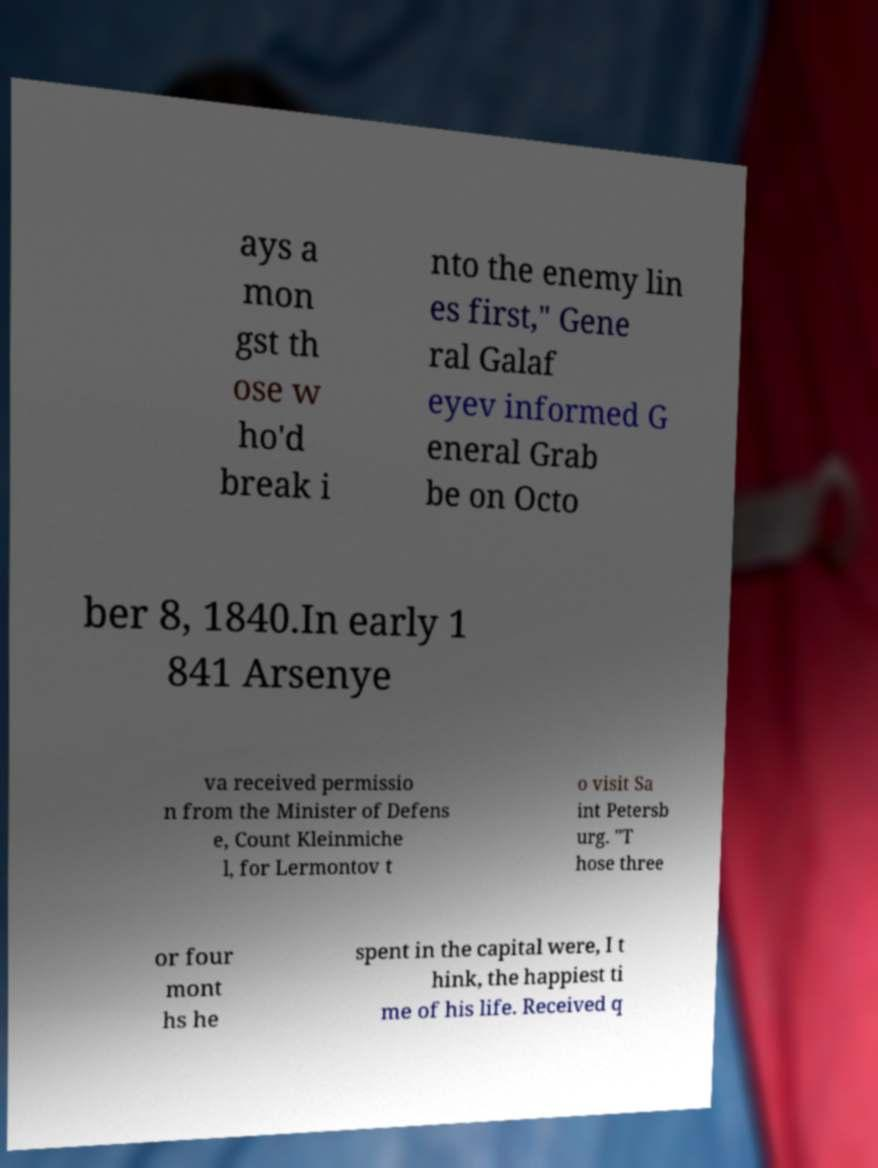Please read and relay the text visible in this image. What does it say? ays a mon gst th ose w ho'd break i nto the enemy lin es first," Gene ral Galaf eyev informed G eneral Grab be on Octo ber 8, 1840.In early 1 841 Arsenye va received permissio n from the Minister of Defens e, Count Kleinmiche l, for Lermontov t o visit Sa int Petersb urg. "T hose three or four mont hs he spent in the capital were, I t hink, the happiest ti me of his life. Received q 